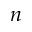Convert formula to latex. <formula><loc_0><loc_0><loc_500><loc_500>n</formula> 